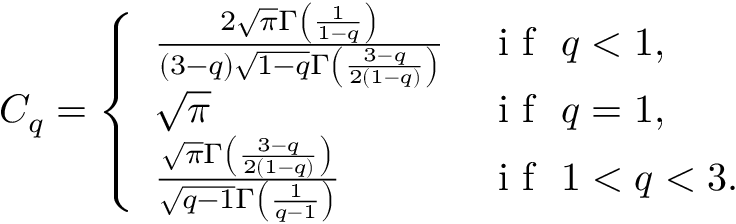<formula> <loc_0><loc_0><loc_500><loc_500>C _ { q } = \left \{ \begin{array} { l l } { \frac { 2 \sqrt { \pi } \Gamma \left ( \frac { 1 } { 1 - q } \right ) } { \left ( 3 - q \right ) \sqrt { 1 - q } \Gamma \left ( \frac { 3 - q } { 2 \left ( 1 - q \right ) } \right ) } } & { i f \ q < 1 , } \\ { \sqrt { \pi } } & { i f \ q = 1 , } \\ { \frac { \sqrt { \pi } \Gamma \left ( \frac { 3 - q } { 2 \left ( 1 - q \right ) } \right ) } { \sqrt { q - 1 } \Gamma \left ( \frac { 1 } { q - 1 } \right ) } } & { i f \ 1 < q < 3 . } \end{array}</formula> 